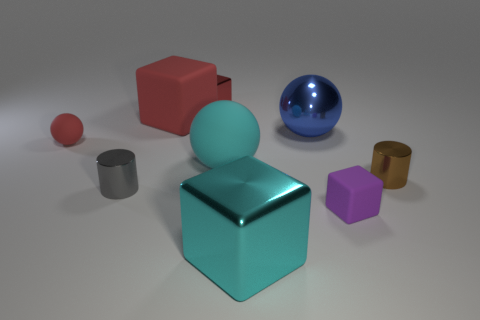Is there a pattern in the arrangement of the objects in the image? There isn't a clear pattern to the arrangement of these objects; they seem to be placed randomly. However, this scattered layout may be intended to showcase the individual characteristics of each item, such as shape, color, or size, for a visual contrast. 